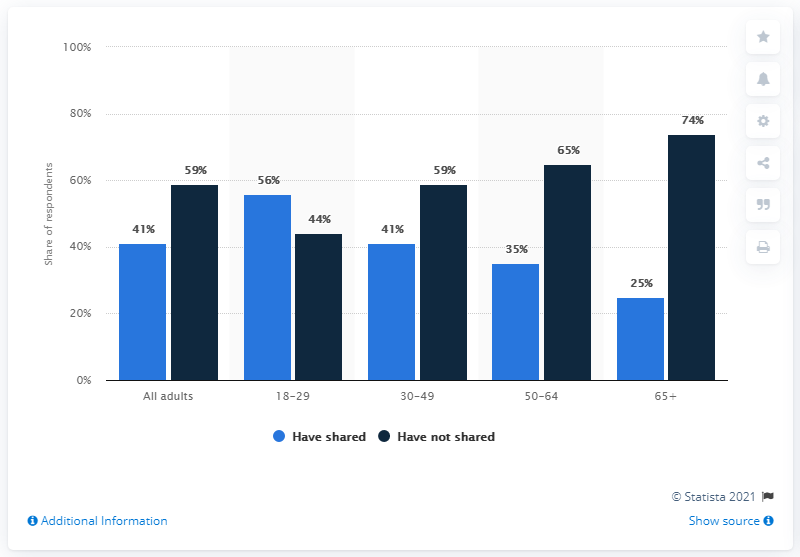Mention a couple of crucial points in this snapshot. In the 50-64 age category, there is a difference between the two bars. Specifically, there is a 30-point difference. The blue bar's highest recorded data was in the 18-29 age category. 